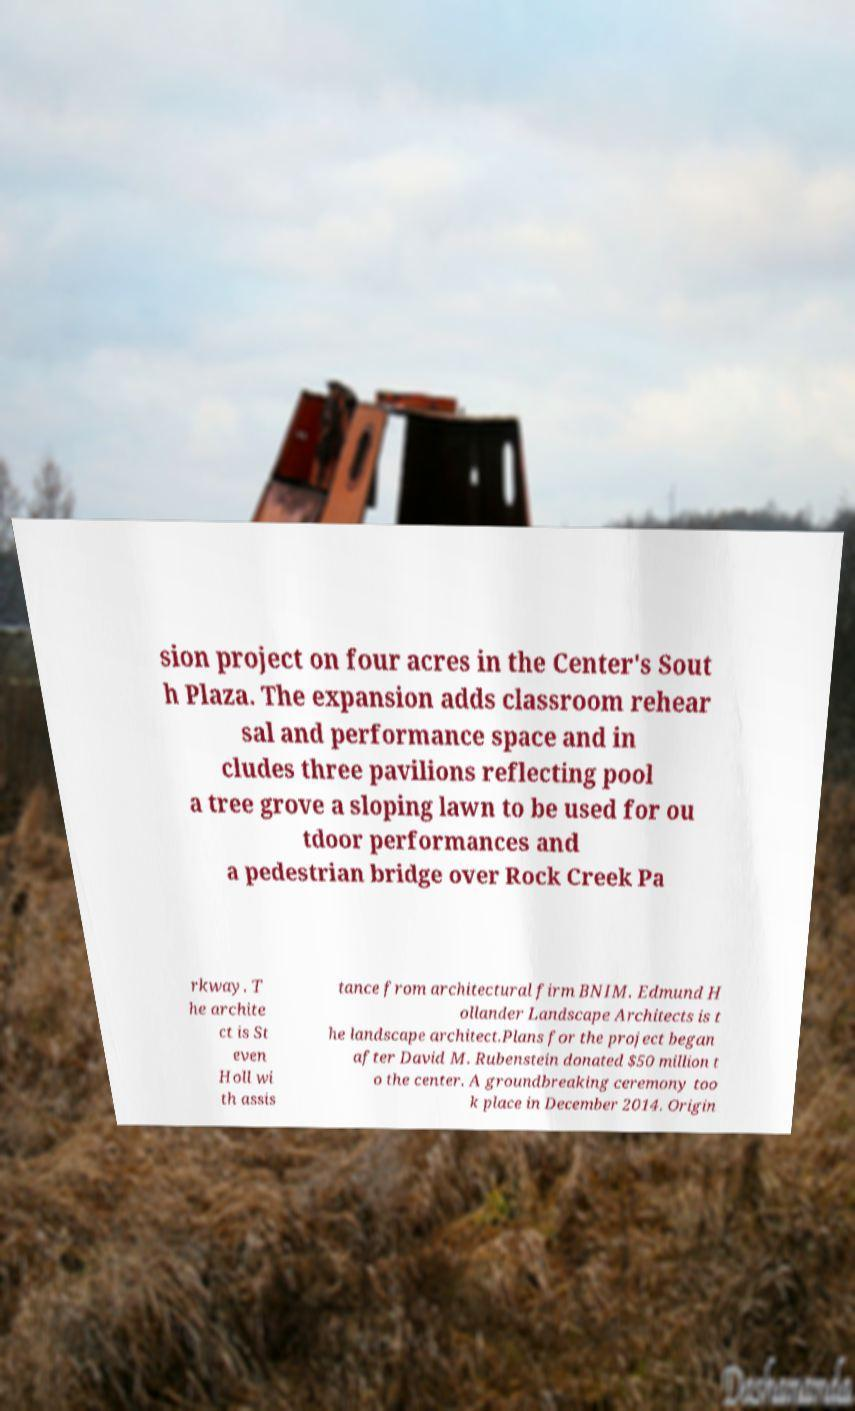Please read and relay the text visible in this image. What does it say? sion project on four acres in the Center's Sout h Plaza. The expansion adds classroom rehear sal and performance space and in cludes three pavilions reflecting pool a tree grove a sloping lawn to be used for ou tdoor performances and a pedestrian bridge over Rock Creek Pa rkway. T he archite ct is St even Holl wi th assis tance from architectural firm BNIM. Edmund H ollander Landscape Architects is t he landscape architect.Plans for the project began after David M. Rubenstein donated $50 million t o the center. A groundbreaking ceremony too k place in December 2014. Origin 